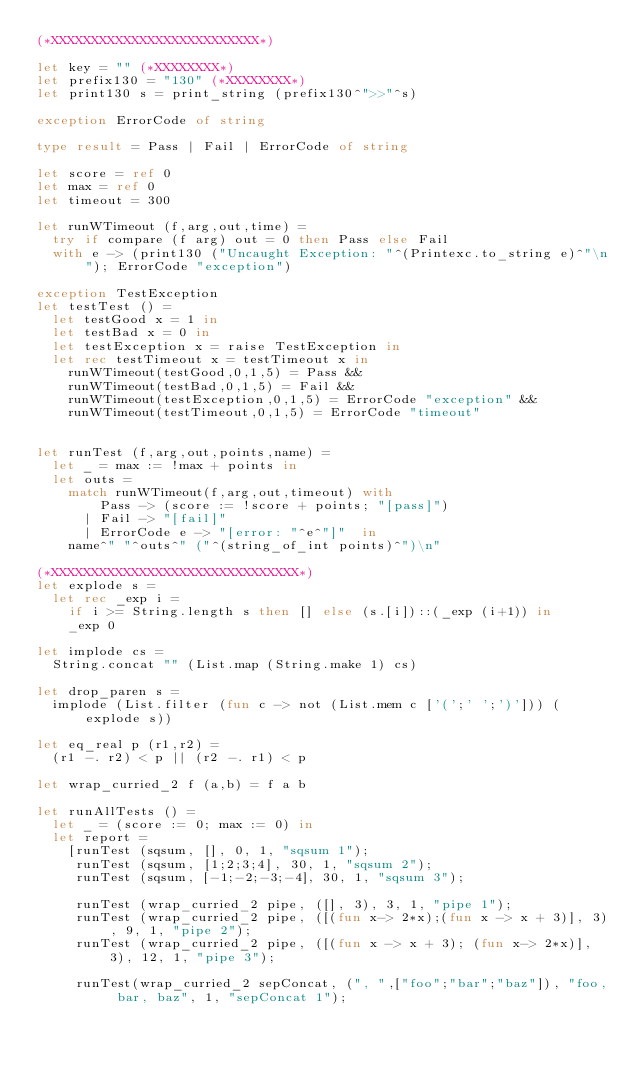<code> <loc_0><loc_0><loc_500><loc_500><_OCaml_>(*XXXXXXXXXXXXXXXXXXXXXXXXXX*)

let key = "" (*XXXXXXXX*)
let prefix130 = "130" (*XXXXXXXX*)
let print130 s = print_string (prefix130^">>"^s)

exception ErrorCode of string

type result = Pass | Fail | ErrorCode of string

let score = ref 0
let max = ref 0
let timeout = 300

let runWTimeout (f,arg,out,time) = 
  try if compare (f arg) out = 0 then Pass else Fail
  with e -> (print130 ("Uncaught Exception: "^(Printexc.to_string e)^"\n"); ErrorCode "exception") 

exception TestException
let testTest () =
  let testGood x = 1 in
  let testBad x = 0 in 
  let testException x = raise TestException in
  let rec testTimeout x = testTimeout x in
    runWTimeout(testGood,0,1,5) = Pass &&  
    runWTimeout(testBad,0,1,5) = Fail &&  
    runWTimeout(testException,0,1,5) = ErrorCode "exception" && 
    runWTimeout(testTimeout,0,1,5) = ErrorCode "timeout"


let runTest (f,arg,out,points,name) =
  let _ = max := !max + points in
  let outs = 
    match runWTimeout(f,arg,out,timeout) with 
        Pass -> (score := !score + points; "[pass]")
      | Fail -> "[fail]"
      | ErrorCode e -> "[error: "^e^"]"  in
    name^" "^outs^" ("^(string_of_int points)^")\n"

(*XXXXXXXXXXXXXXXXXXXXXXXXXXXXXXX*)
let explode s = 
  let rec _exp i = 
    if i >= String.length s then [] else (s.[i])::(_exp (i+1)) in
    _exp 0

let implode cs = 
  String.concat "" (List.map (String.make 1) cs)

let drop_paren s = 
  implode (List.filter (fun c -> not (List.mem c ['(';' ';')'])) (explode s))

let eq_real p (r1,r2) = 
  (r1 -. r2) < p || (r2 -. r1) < p

let wrap_curried_2 f (a,b) = f a b

let runAllTests () =
  let _ = (score := 0; max := 0) in
  let report = 
    [runTest (sqsum, [], 0, 1, "sqsum 1");
     runTest (sqsum, [1;2;3;4], 30, 1, "sqsum 2");
     runTest (sqsum, [-1;-2;-3;-4], 30, 1, "sqsum 3");

     runTest (wrap_curried_2 pipe, ([], 3), 3, 1, "pipe 1");
     runTest (wrap_curried_2 pipe, ([(fun x-> 2*x);(fun x -> x + 3)], 3), 9, 1, "pipe 2");
     runTest (wrap_curried_2 pipe, ([(fun x -> x + 3); (fun x-> 2*x)], 3), 12, 1, "pipe 3");

     runTest(wrap_curried_2 sepConcat, (", ",["foo";"bar";"baz"]), "foo, bar, baz", 1, "sepConcat 1");</code> 